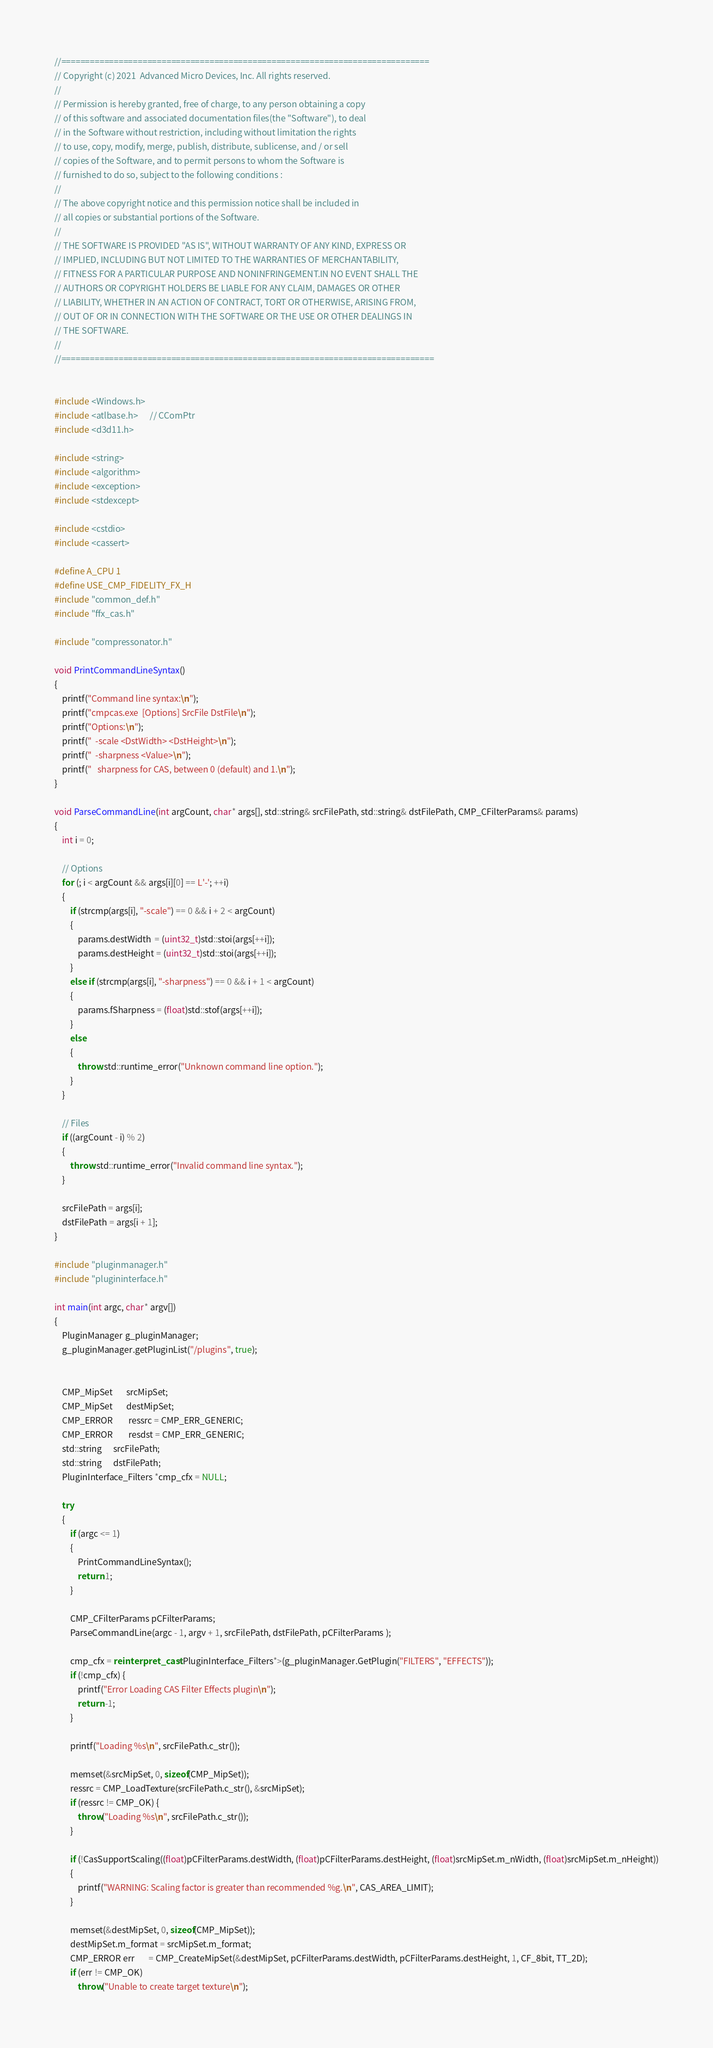Convert code to text. <code><loc_0><loc_0><loc_500><loc_500><_C++_>//=============================================================================
// Copyright (c) 2021  Advanced Micro Devices, Inc. All rights reserved.
//
// Permission is hereby granted, free of charge, to any person obtaining a copy
// of this software and associated documentation files(the "Software"), to deal
// in the Software without restriction, including without limitation the rights
// to use, copy, modify, merge, publish, distribute, sublicense, and / or sell
// copies of the Software, and to permit persons to whom the Software is
// furnished to do so, subject to the following conditions :
//
// The above copyright notice and this permission notice shall be included in
// all copies or substantial portions of the Software.
//
// THE SOFTWARE IS PROVIDED "AS IS", WITHOUT WARRANTY OF ANY KIND, EXPRESS OR
// IMPLIED, INCLUDING BUT NOT LIMITED TO THE WARRANTIES OF MERCHANTABILITY,
// FITNESS FOR A PARTICULAR PURPOSE AND NONINFRINGEMENT.IN NO EVENT SHALL THE
// AUTHORS OR COPYRIGHT HOLDERS BE LIABLE FOR ANY CLAIM, DAMAGES OR OTHER
// LIABILITY, WHETHER IN AN ACTION OF CONTRACT, TORT OR OTHERWISE, ARISING FROM,
// OUT OF OR IN CONNECTION WITH THE SOFTWARE OR THE USE OR OTHER DEALINGS IN
// THE SOFTWARE.
//
//==============================================================================


#include <Windows.h>
#include <atlbase.h>      // CComPtr
#include <d3d11.h>

#include <string>
#include <algorithm>
#include <exception>
#include <stdexcept>

#include <cstdio>
#include <cassert>

#define A_CPU 1
#define USE_CMP_FIDELITY_FX_H
#include "common_def.h"
#include "ffx_cas.h"

#include "compressonator.h"

void PrintCommandLineSyntax()
{
    printf("Command line syntax:\n");
    printf("cmpcas.exe  [Options] SrcFile DstFile\n");
    printf("Options:\n");
    printf("  -scale <DstWidth> <DstHeight>\n");
    printf("  -sharpness <Value>\n");
    printf("   sharpness for CAS, between 0 (default) and 1.\n");
}

void ParseCommandLine(int argCount, char* args[], std::string& srcFilePath, std::string& dstFilePath, CMP_CFilterParams& params)
{
    int i = 0;

    // Options
    for (; i < argCount && args[i][0] == L'-'; ++i)
    {
        if (strcmp(args[i], "-scale") == 0 && i + 2 < argCount)
        {
            params.destWidth  = (uint32_t)std::stoi(args[++i]);
            params.destHeight = (uint32_t)std::stoi(args[++i]);
        }
        else if (strcmp(args[i], "-sharpness") == 0 && i + 1 < argCount)
        {
            params.fSharpness = (float)std::stof(args[++i]);
        }
        else
        {
            throw std::runtime_error("Unknown command line option.");
        }
    }

    // Files
    if ((argCount - i) % 2)
    {
        throw std::runtime_error("Invalid command line syntax.");
    }

    srcFilePath = args[i];
    dstFilePath = args[i + 1];
}

#include "pluginmanager.h"
#include "plugininterface.h"

int main(int argc, char* argv[])
{
    PluginManager g_pluginManager;
    g_pluginManager.getPluginList("/plugins", true);


    CMP_MipSet       srcMipSet;
    CMP_MipSet       destMipSet;
    CMP_ERROR        ressrc = CMP_ERR_GENERIC;
    CMP_ERROR        resdst = CMP_ERR_GENERIC;
    std::string      srcFilePath;
    std::string      dstFilePath;
    PluginInterface_Filters *cmp_cfx = NULL;

    try
    {
        if (argc <= 1)
        {
            PrintCommandLineSyntax();
            return 1;
        }

        CMP_CFilterParams pCFilterParams;
        ParseCommandLine(argc - 1, argv + 1, srcFilePath, dstFilePath, pCFilterParams );

        cmp_cfx = reinterpret_cast<PluginInterface_Filters*>(g_pluginManager.GetPlugin("FILTERS", "EFFECTS"));
        if (!cmp_cfx) {
            printf("Error Loading CAS Filter Effects plugin\n");
            return -1;
        }

        printf("Loading %s\n", srcFilePath.c_str());

        memset(&srcMipSet, 0, sizeof(CMP_MipSet));
        ressrc = CMP_LoadTexture(srcFilePath.c_str(), &srcMipSet);
        if (ressrc != CMP_OK) {
            throw("Loading %s\n", srcFilePath.c_str());
        }

        if (!CasSupportScaling((float)pCFilterParams.destWidth, (float)pCFilterParams.destHeight, (float)srcMipSet.m_nWidth, (float)srcMipSet.m_nHeight))
        {
            printf("WARNING: Scaling factor is greater than recommended %g.\n", CAS_AREA_LIMIT);
        }

        memset(&destMipSet, 0, sizeof(CMP_MipSet));
        destMipSet.m_format = srcMipSet.m_format;
        CMP_ERROR err       = CMP_CreateMipSet(&destMipSet, pCFilterParams.destWidth, pCFilterParams.destHeight, 1, CF_8bit, TT_2D);
        if (err != CMP_OK)
            throw("Unable to create target texture\n");
</code> 